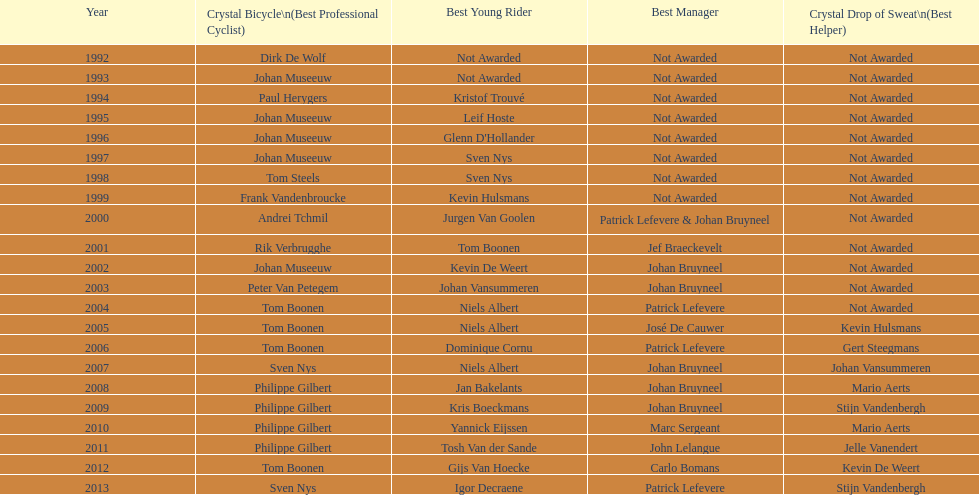What is the overall count of appearances for johan bryneel's name on all these lists? 6. Can you give me this table as a dict? {'header': ['Year', 'Crystal Bicycle\\n(Best Professional Cyclist)', 'Best Young Rider', 'Best Manager', 'Crystal Drop of Sweat\\n(Best Helper)'], 'rows': [['1992', 'Dirk De Wolf', 'Not Awarded', 'Not Awarded', 'Not Awarded'], ['1993', 'Johan Museeuw', 'Not Awarded', 'Not Awarded', 'Not Awarded'], ['1994', 'Paul Herygers', 'Kristof Trouvé', 'Not Awarded', 'Not Awarded'], ['1995', 'Johan Museeuw', 'Leif Hoste', 'Not Awarded', 'Not Awarded'], ['1996', 'Johan Museeuw', "Glenn D'Hollander", 'Not Awarded', 'Not Awarded'], ['1997', 'Johan Museeuw', 'Sven Nys', 'Not Awarded', 'Not Awarded'], ['1998', 'Tom Steels', 'Sven Nys', 'Not Awarded', 'Not Awarded'], ['1999', 'Frank Vandenbroucke', 'Kevin Hulsmans', 'Not Awarded', 'Not Awarded'], ['2000', 'Andrei Tchmil', 'Jurgen Van Goolen', 'Patrick Lefevere & Johan Bruyneel', 'Not Awarded'], ['2001', 'Rik Verbrugghe', 'Tom Boonen', 'Jef Braeckevelt', 'Not Awarded'], ['2002', 'Johan Museeuw', 'Kevin De Weert', 'Johan Bruyneel', 'Not Awarded'], ['2003', 'Peter Van Petegem', 'Johan Vansummeren', 'Johan Bruyneel', 'Not Awarded'], ['2004', 'Tom Boonen', 'Niels Albert', 'Patrick Lefevere', 'Not Awarded'], ['2005', 'Tom Boonen', 'Niels Albert', 'José De Cauwer', 'Kevin Hulsmans'], ['2006', 'Tom Boonen', 'Dominique Cornu', 'Patrick Lefevere', 'Gert Steegmans'], ['2007', 'Sven Nys', 'Niels Albert', 'Johan Bruyneel', 'Johan Vansummeren'], ['2008', 'Philippe Gilbert', 'Jan Bakelants', 'Johan Bruyneel', 'Mario Aerts'], ['2009', 'Philippe Gilbert', 'Kris Boeckmans', 'Johan Bruyneel', 'Stijn Vandenbergh'], ['2010', 'Philippe Gilbert', 'Yannick Eijssen', 'Marc Sergeant', 'Mario Aerts'], ['2011', 'Philippe Gilbert', 'Tosh Van der Sande', 'John Lelangue', 'Jelle Vanendert'], ['2012', 'Tom Boonen', 'Gijs Van Hoecke', 'Carlo Bomans', 'Kevin De Weert'], ['2013', 'Sven Nys', 'Igor Decraene', 'Patrick Lefevere', 'Stijn Vandenbergh']]} 